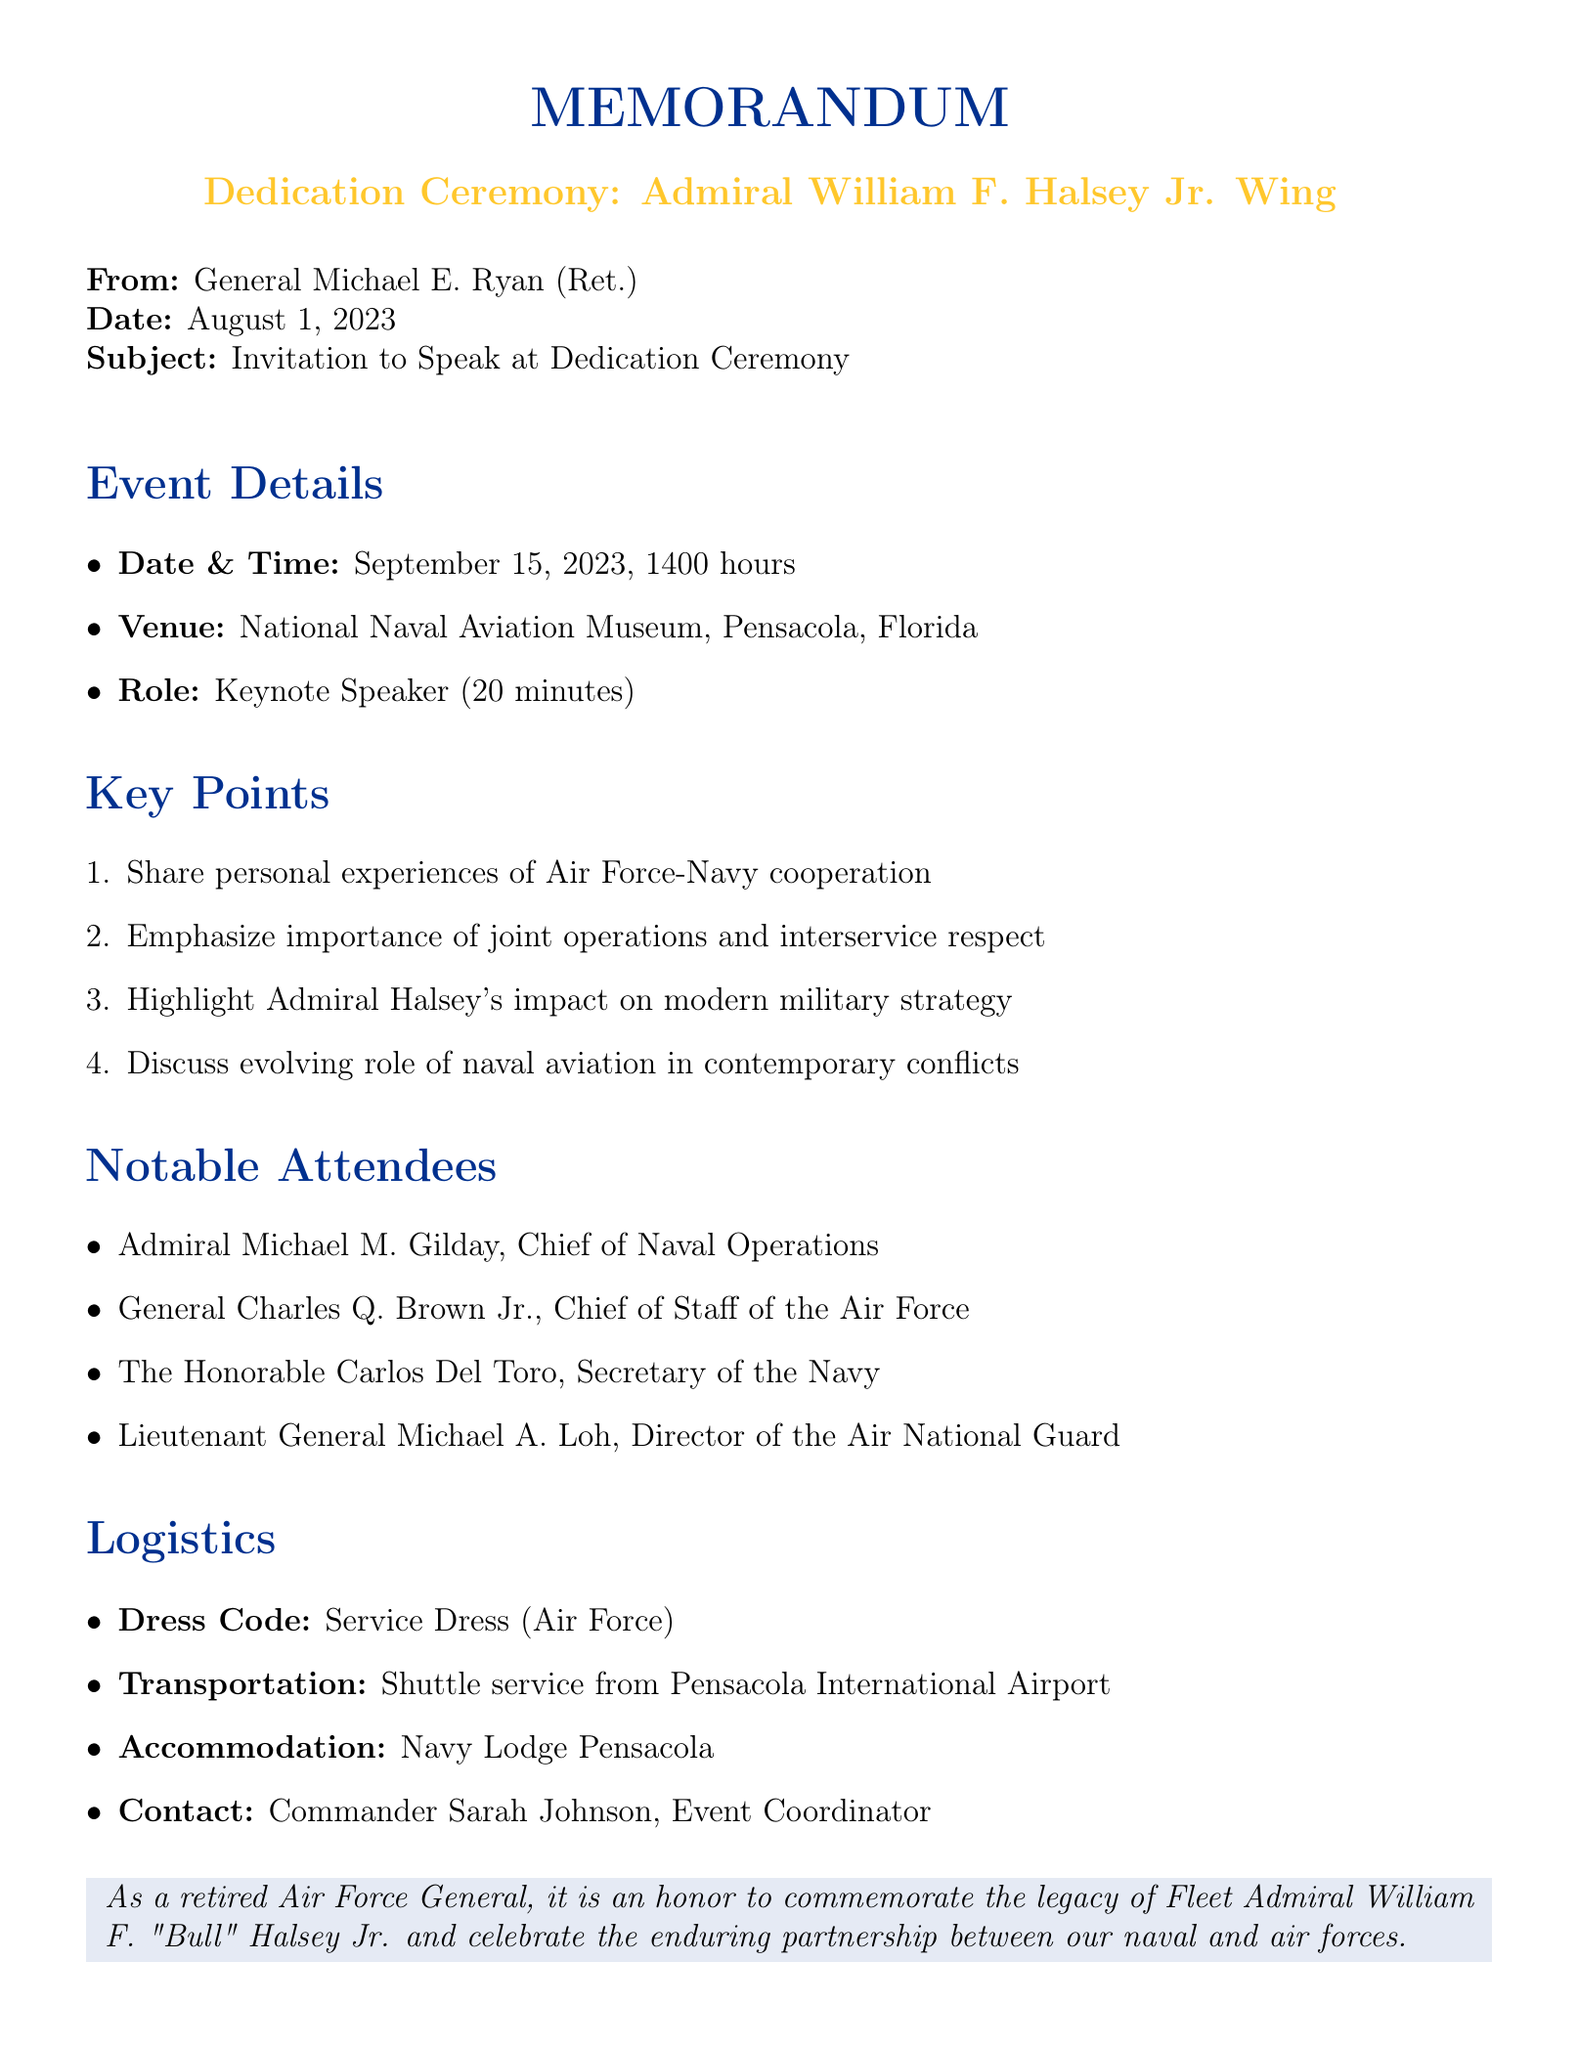What is the date of the dedication ceremony? The date is specified in the event details section, which is September 15, 2023.
Answer: September 15, 2023 Who is the keynote speaker at the ceremony? The document identifies General Michael E. Ryan (Ret.) as the keynote speaker in the speaker invitation section.
Answer: General Michael E. Ryan (Ret.) What is the duration of the keynote speech? The duration of the speech is mentioned in the speaker invitation section, which states it is 20 minutes.
Answer: 20 minutes Which war did Admiral Halsey command the South Pacific Area during? The document discusses Admiral Halsey's achievements and mentions World War II as the war he commanded during.
Answer: World War II What is one of the educational programs offered by the museum? The educational programs are listed in the museum wing features section, where youth leadership seminars are mentioned.
Answer: Youth leadership seminars What is the dress code for the event? The document specifies the dress code in the logistics section, indicating Service Dress Blue (Navy) / Service Dress (Air Force).
Answer: Service Dress Blue (Navy) / Service Dress (Air Force) Name one of the notable attendees at the ceremony. The notable attendees are provided in the document, where Admiral Michael M. Gilday is listed among others.
Answer: Admiral Michael M. Gilday What role did Admiral Halsey play in the Battle of Leyte Gulf? The notable achievements section mentions Admiral Halsey's role in the Battle of Leyte Gulf as crucial.
Answer: Crucial 